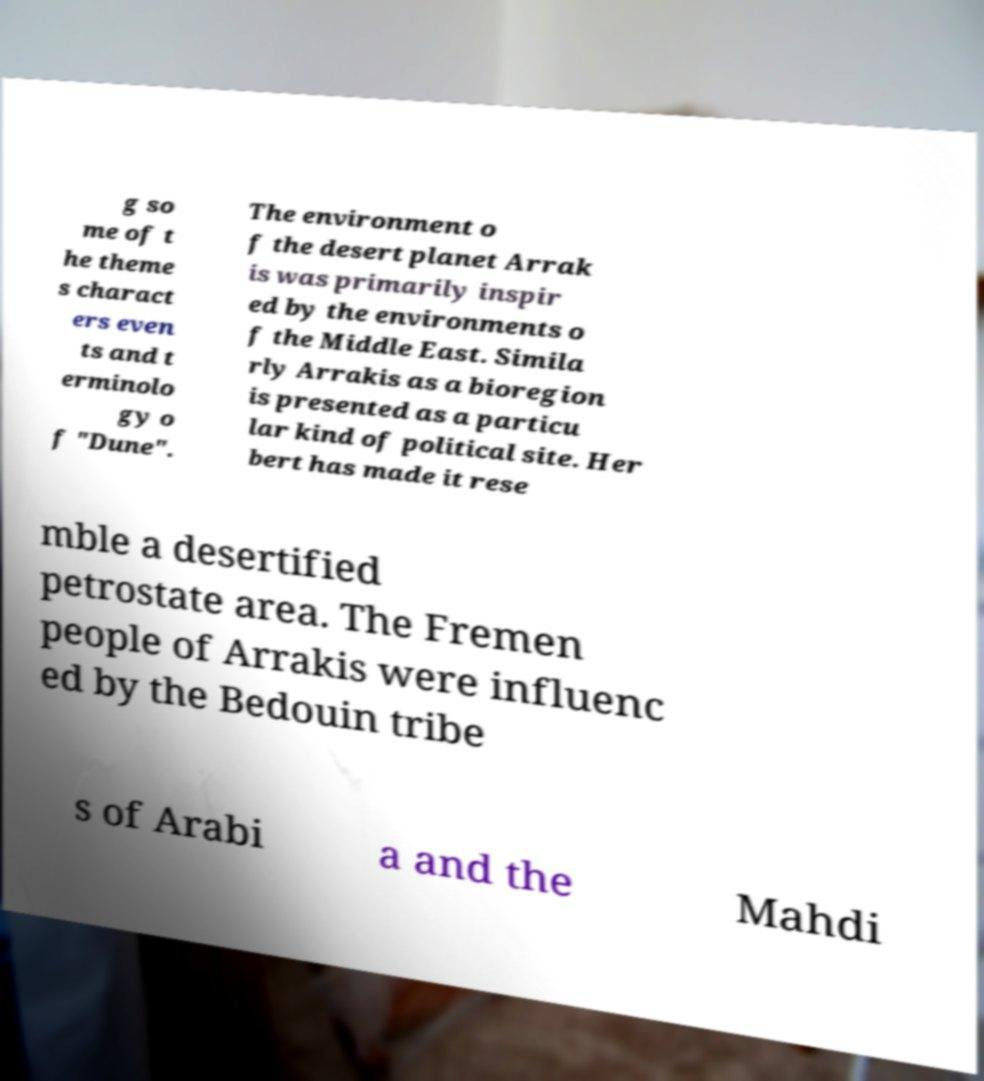Please identify and transcribe the text found in this image. g so me of t he theme s charact ers even ts and t erminolo gy o f "Dune". The environment o f the desert planet Arrak is was primarily inspir ed by the environments o f the Middle East. Simila rly Arrakis as a bioregion is presented as a particu lar kind of political site. Her bert has made it rese mble a desertified petrostate area. The Fremen people of Arrakis were influenc ed by the Bedouin tribe s of Arabi a and the Mahdi 